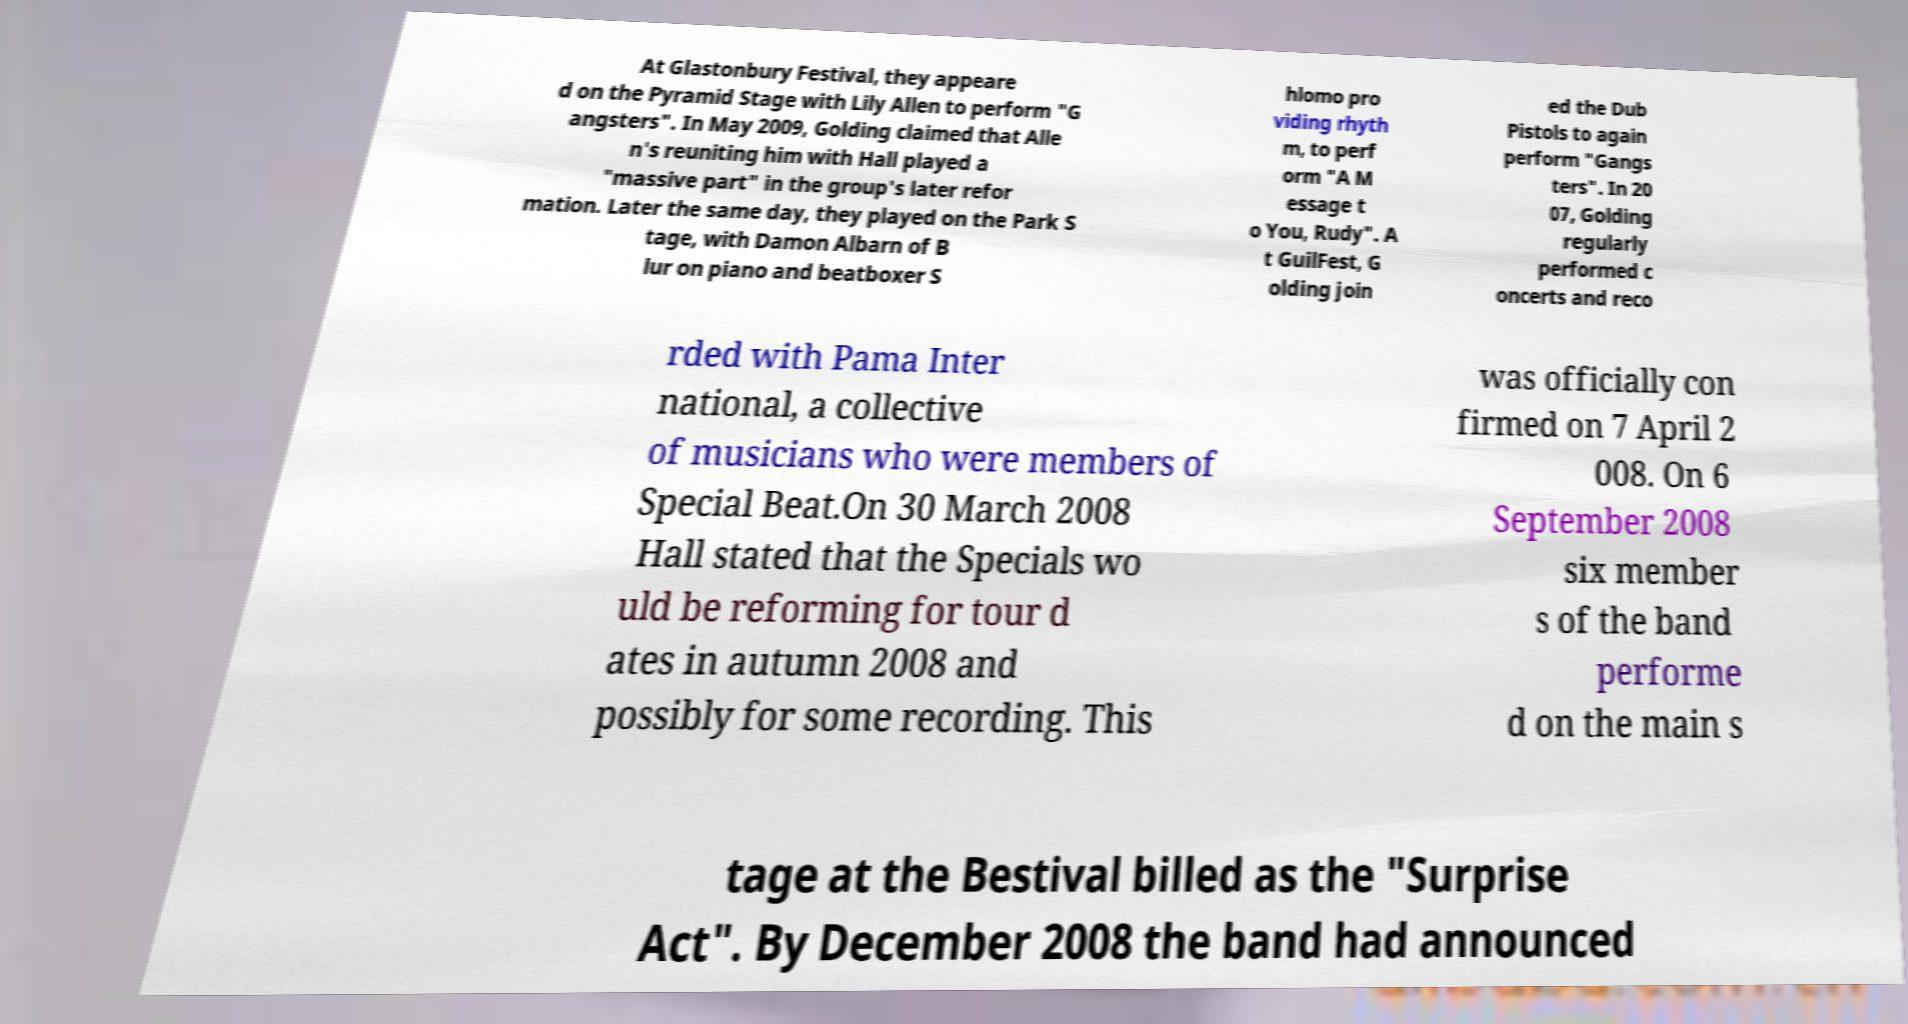Can you accurately transcribe the text from the provided image for me? At Glastonbury Festival, they appeare d on the Pyramid Stage with Lily Allen to perform "G angsters". In May 2009, Golding claimed that Alle n's reuniting him with Hall played a "massive part" in the group's later refor mation. Later the same day, they played on the Park S tage, with Damon Albarn of B lur on piano and beatboxer S hlomo pro viding rhyth m, to perf orm "A M essage t o You, Rudy". A t GuilFest, G olding join ed the Dub Pistols to again perform "Gangs ters". In 20 07, Golding regularly performed c oncerts and reco rded with Pama Inter national, a collective of musicians who were members of Special Beat.On 30 March 2008 Hall stated that the Specials wo uld be reforming for tour d ates in autumn 2008 and possibly for some recording. This was officially con firmed on 7 April 2 008. On 6 September 2008 six member s of the band performe d on the main s tage at the Bestival billed as the "Surprise Act". By December 2008 the band had announced 